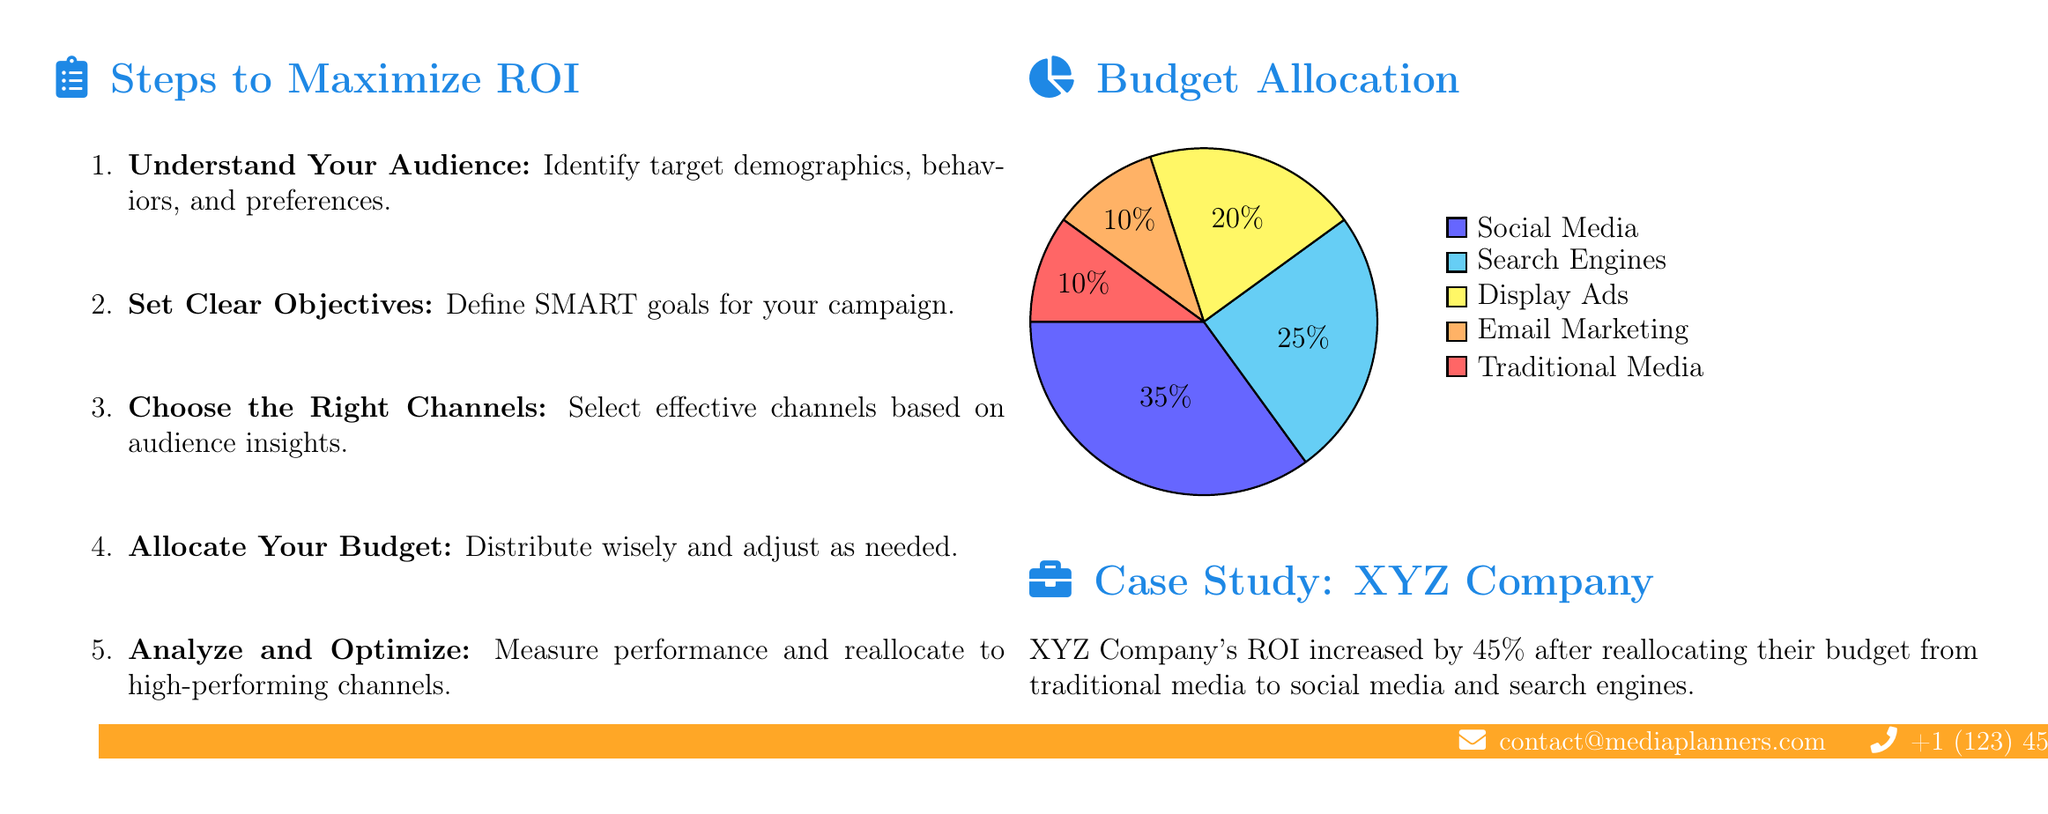What is the title of the guide? The title of the guide is stated prominently at the top of the document.
Answer: Maximizing ROI on Your Advertising Budget What is the first step listed to maximize ROI? The first step is clearly listed in the steps section of the document.
Answer: Understand Your Audience What percentage of the budget is allocated to Social Media? The budget allocation is displayed in a pie chart with each segment labeled.
Answer: 35 How much did XYZ Company's ROI increase after budget reallocation? The case study mentions the specific percentage increase in ROI for XYZ Company.
Answer: 45% Which advertising channel has the lowest budget allocation? The pie chart shows the percentage distribution of the budget across different channels.
Answer: Traditional Media What are the SMART goals referred to in the document? The document mentions setting clear objectives but does not define SMART.
Answer: not specified What is the main color used in the flyer? The main color is specified and used throughout the document's design elements.
Answer: Blue What channel received 20% of the budget? The pie chart indicates the specific percentage allocated to each channel.
Answer: Display Ads What is the contact email provided at the bottom of the document? The contact information section includes the email address for further inquiries.
Answer: contact@mediaplanners.com 